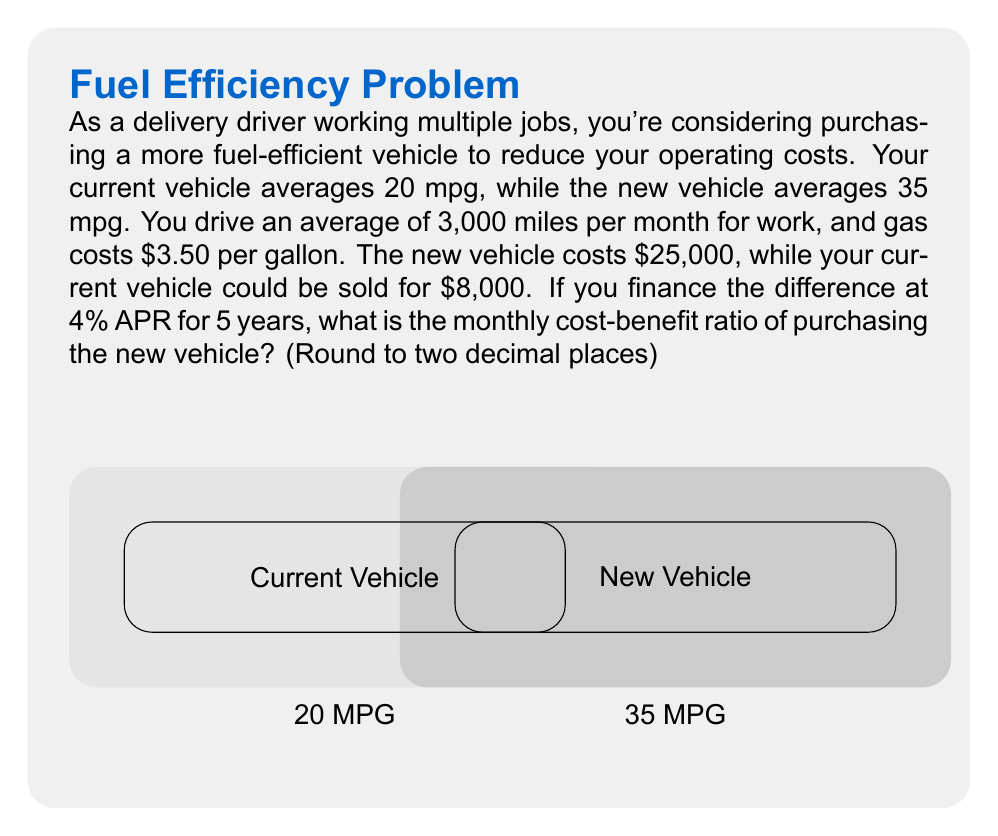What is the answer to this math problem? Let's break this down step-by-step:

1) First, calculate the monthly fuel costs for both vehicles:
   - Current vehicle: $\frac{3000 \text{ miles}}{20 \text{ mpg}} \times $3.50/gallon = $525/month$
   - New vehicle: $\frac{3000 \text{ miles}}{35 \text{ mpg}} \times $3.50/gallon = $300/month$

2) Monthly fuel savings: $525 - $300 = $225

3) Calculate the financed amount:
   $25,000 (new vehicle) - $8,000 (sale of current vehicle) = $17,000

4) Use the monthly payment formula to calculate the monthly car payment:
   $P = L\frac{r(1+r)^n}{(1+r)^n-1}$
   Where:
   $P$ = monthly payment
   $L$ = loan amount ($17,000)
   $r$ = monthly interest rate (4% / 12 = 0.0033333)
   $n$ = number of payments (5 years * 12 months = 60)

   $P = 17000 \times \frac{0.0033333(1+0.0033333)^{60}}{(1+0.0033333)^{60}-1} = $313.15$

5) Net monthly cost: $313.15 (car payment) - $225 (fuel savings) = $88.15

6) Cost-benefit ratio: $\frac{\text{Cost}}{\text{Benefit}} = \frac{$313.15}{$225} = 1.39$
Answer: 1.39 